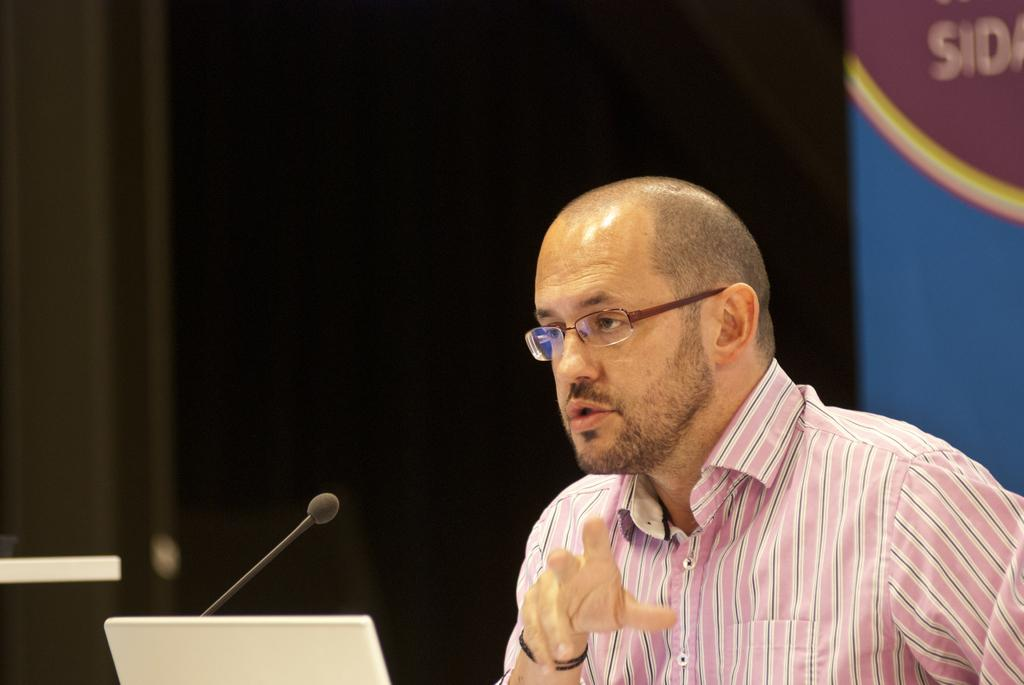Who or what is the main subject in the image? There is a person in the image. What is the person wearing? The person is wearing a white and pink color shirt. What objects are in front of the person? There is a laptop and a microphone in front of the person. Can you describe the background of the image? The background of the image is dark. How many dogs are visible in the image? There are no dogs present in the image. What type of alley can be seen in the background of the image? There is no alley visible in the image; the background is dark. 